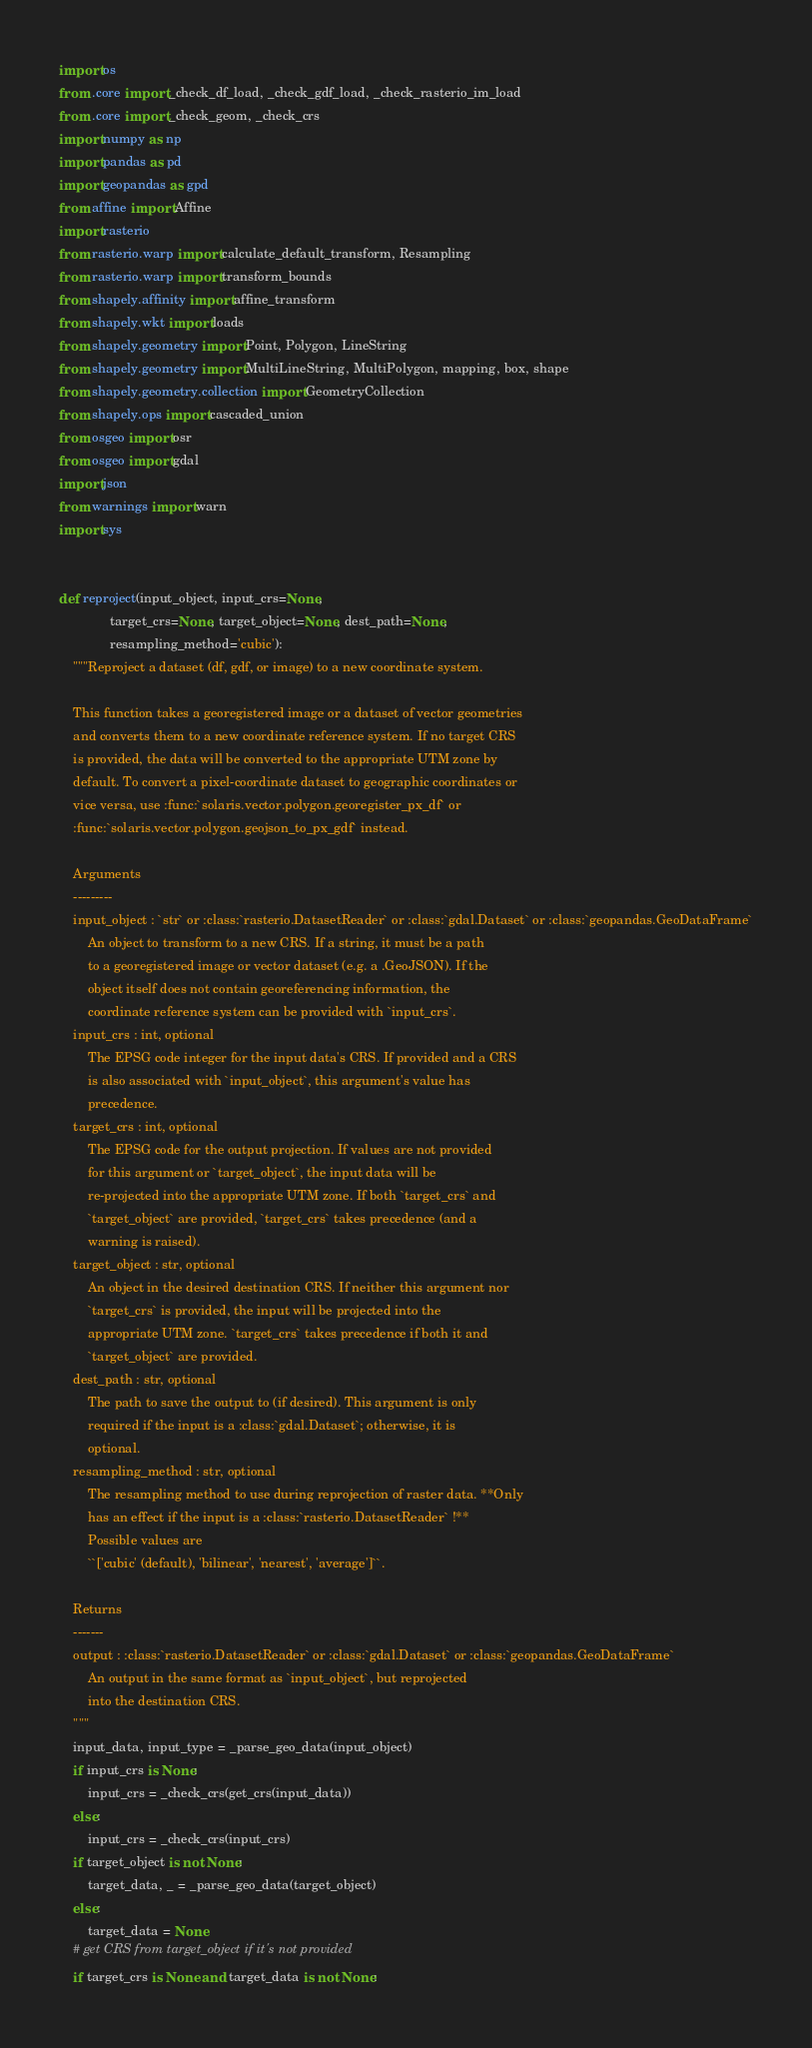<code> <loc_0><loc_0><loc_500><loc_500><_Python_>import os
from .core import _check_df_load, _check_gdf_load, _check_rasterio_im_load
from .core import _check_geom, _check_crs
import numpy as np
import pandas as pd
import geopandas as gpd
from affine import Affine
import rasterio
from rasterio.warp import calculate_default_transform, Resampling
from rasterio.warp import transform_bounds
from shapely.affinity import affine_transform
from shapely.wkt import loads
from shapely.geometry import Point, Polygon, LineString
from shapely.geometry import MultiLineString, MultiPolygon, mapping, box, shape
from shapely.geometry.collection import GeometryCollection
from shapely.ops import cascaded_union
from osgeo import osr
from osgeo import gdal
import json
from warnings import warn
import sys


def reproject(input_object, input_crs=None,
              target_crs=None, target_object=None, dest_path=None,
              resampling_method='cubic'):
    """Reproject a dataset (df, gdf, or image) to a new coordinate system.

    This function takes a georegistered image or a dataset of vector geometries
    and converts them to a new coordinate reference system. If no target CRS
    is provided, the data will be converted to the appropriate UTM zone by
    default. To convert a pixel-coordinate dataset to geographic coordinates or
    vice versa, use :func:`solaris.vector.polygon.georegister_px_df` or
    :func:`solaris.vector.polygon.geojson_to_px_gdf` instead.

    Arguments
    ---------
    input_object : `str` or :class:`rasterio.DatasetReader` or :class:`gdal.Dataset` or :class:`geopandas.GeoDataFrame`
        An object to transform to a new CRS. If a string, it must be a path
        to a georegistered image or vector dataset (e.g. a .GeoJSON). If the
        object itself does not contain georeferencing information, the
        coordinate reference system can be provided with `input_crs`.
    input_crs : int, optional
        The EPSG code integer for the input data's CRS. If provided and a CRS
        is also associated with `input_object`, this argument's value has
        precedence.
    target_crs : int, optional
        The EPSG code for the output projection. If values are not provided
        for this argument or `target_object`, the input data will be
        re-projected into the appropriate UTM zone. If both `target_crs` and
        `target_object` are provided, `target_crs` takes precedence (and a
        warning is raised).
    target_object : str, optional
        An object in the desired destination CRS. If neither this argument nor
        `target_crs` is provided, the input will be projected into the
        appropriate UTM zone. `target_crs` takes precedence if both it and
        `target_object` are provided.
    dest_path : str, optional
        The path to save the output to (if desired). This argument is only
        required if the input is a :class:`gdal.Dataset`; otherwise, it is
        optional.
    resampling_method : str, optional
        The resampling method to use during reprojection of raster data. **Only
        has an effect if the input is a :class:`rasterio.DatasetReader` !**
        Possible values are
        ``['cubic' (default), 'bilinear', 'nearest', 'average']``.

    Returns
    -------
    output : :class:`rasterio.DatasetReader` or :class:`gdal.Dataset` or :class:`geopandas.GeoDataFrame`
        An output in the same format as `input_object`, but reprojected
        into the destination CRS.
    """
    input_data, input_type = _parse_geo_data(input_object)
    if input_crs is None:
        input_crs = _check_crs(get_crs(input_data))
    else:
        input_crs = _check_crs(input_crs)
    if target_object is not None:
        target_data, _ = _parse_geo_data(target_object)
    else:
        target_data = None
    # get CRS from target_object if it's not provided
    if target_crs is None and target_data is not None:</code> 